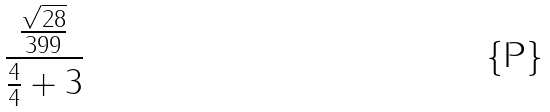Convert formula to latex. <formula><loc_0><loc_0><loc_500><loc_500>\frac { \frac { \sqrt { 2 8 } } { 3 9 9 } } { \frac { 4 } { 4 } + 3 }</formula> 